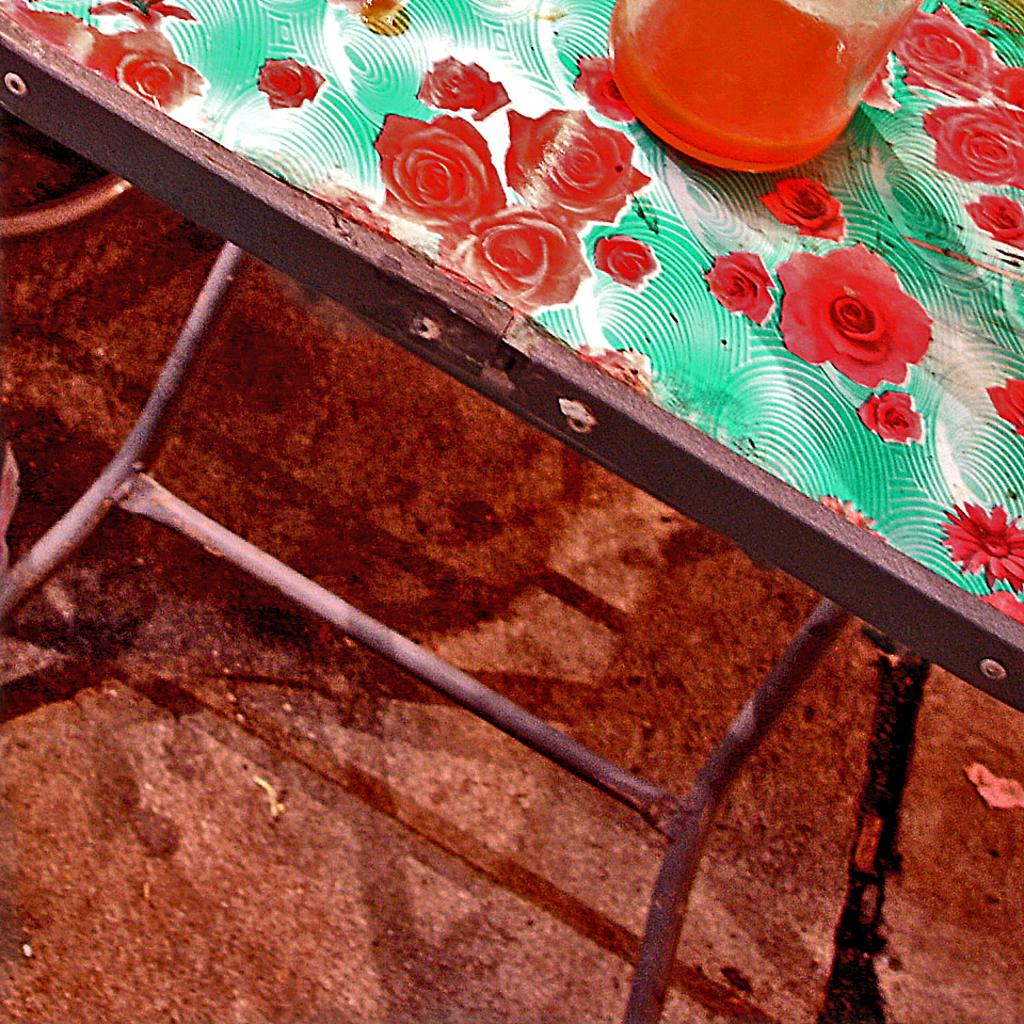What type of furniture is in the image? There is a colorful desk in the image. Where is the desk located in the image? The desk is at the top side of the image. What object is on the desk? There is a glass on the desk. What type of punishment is being given to the nation in the image? There is no mention of a nation or punishment in the image; it only features a colorful desk and a glass on it. 